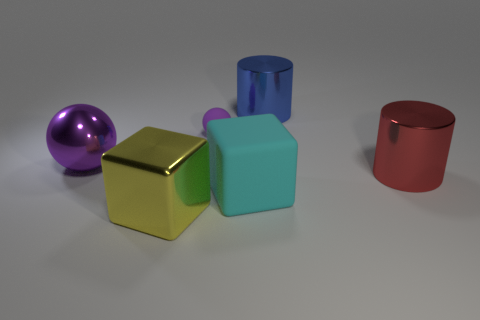Subtract all red cylinders. Subtract all red blocks. How many cylinders are left? 1 Add 2 tiny purple objects. How many objects exist? 8 Subtract all balls. How many objects are left? 4 Add 1 small green matte objects. How many small green matte objects exist? 1 Subtract 0 brown cubes. How many objects are left? 6 Subtract all small red shiny cylinders. Subtract all big metallic cylinders. How many objects are left? 4 Add 6 big rubber blocks. How many big rubber blocks are left? 7 